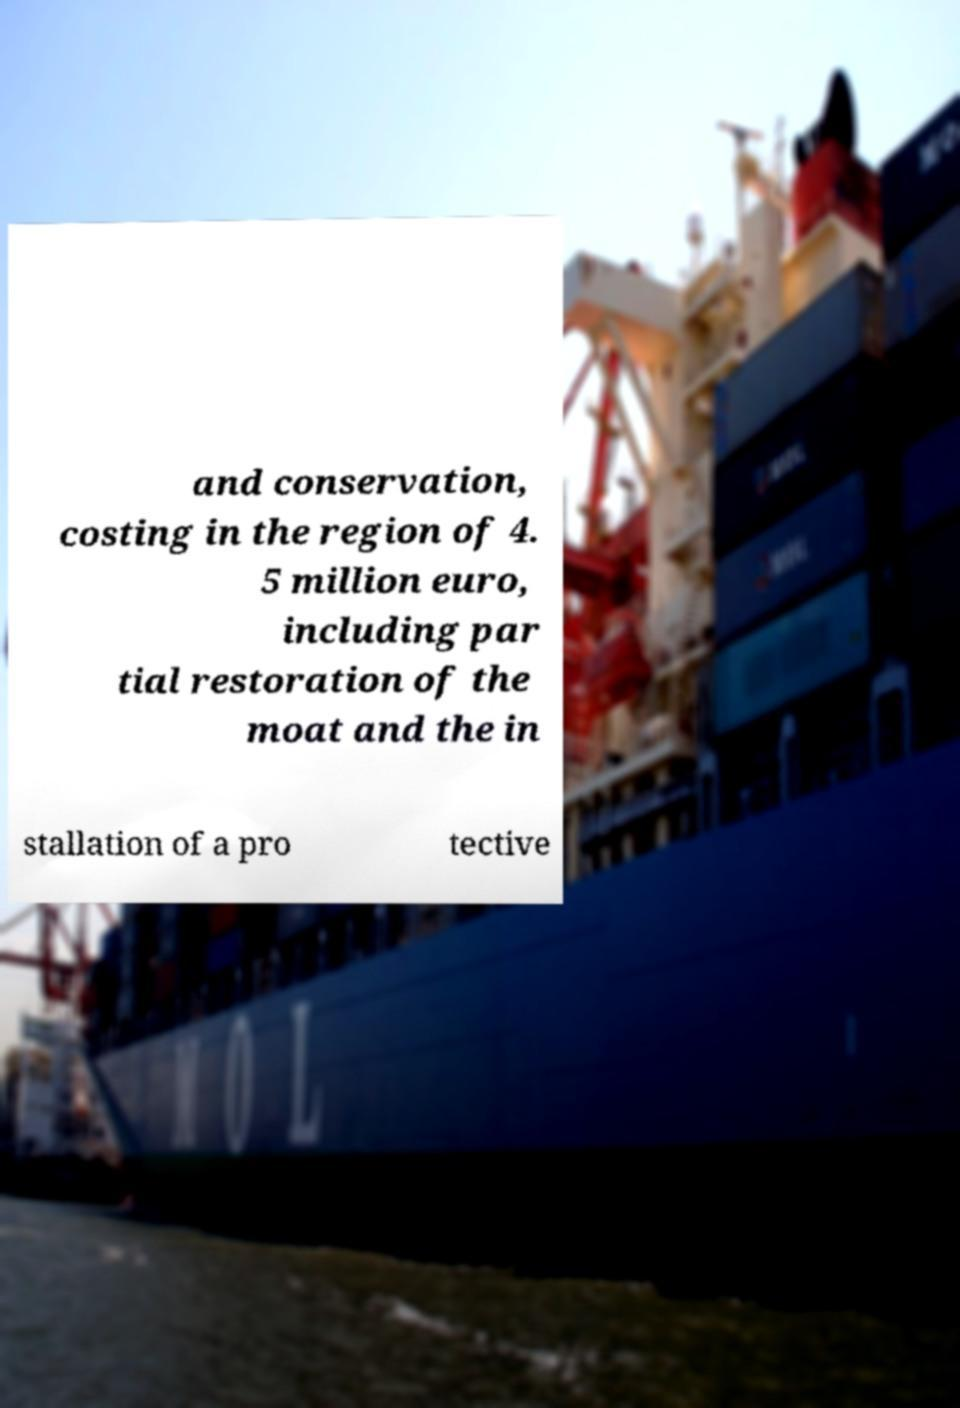Could you assist in decoding the text presented in this image and type it out clearly? and conservation, costing in the region of 4. 5 million euro, including par tial restoration of the moat and the in stallation of a pro tective 